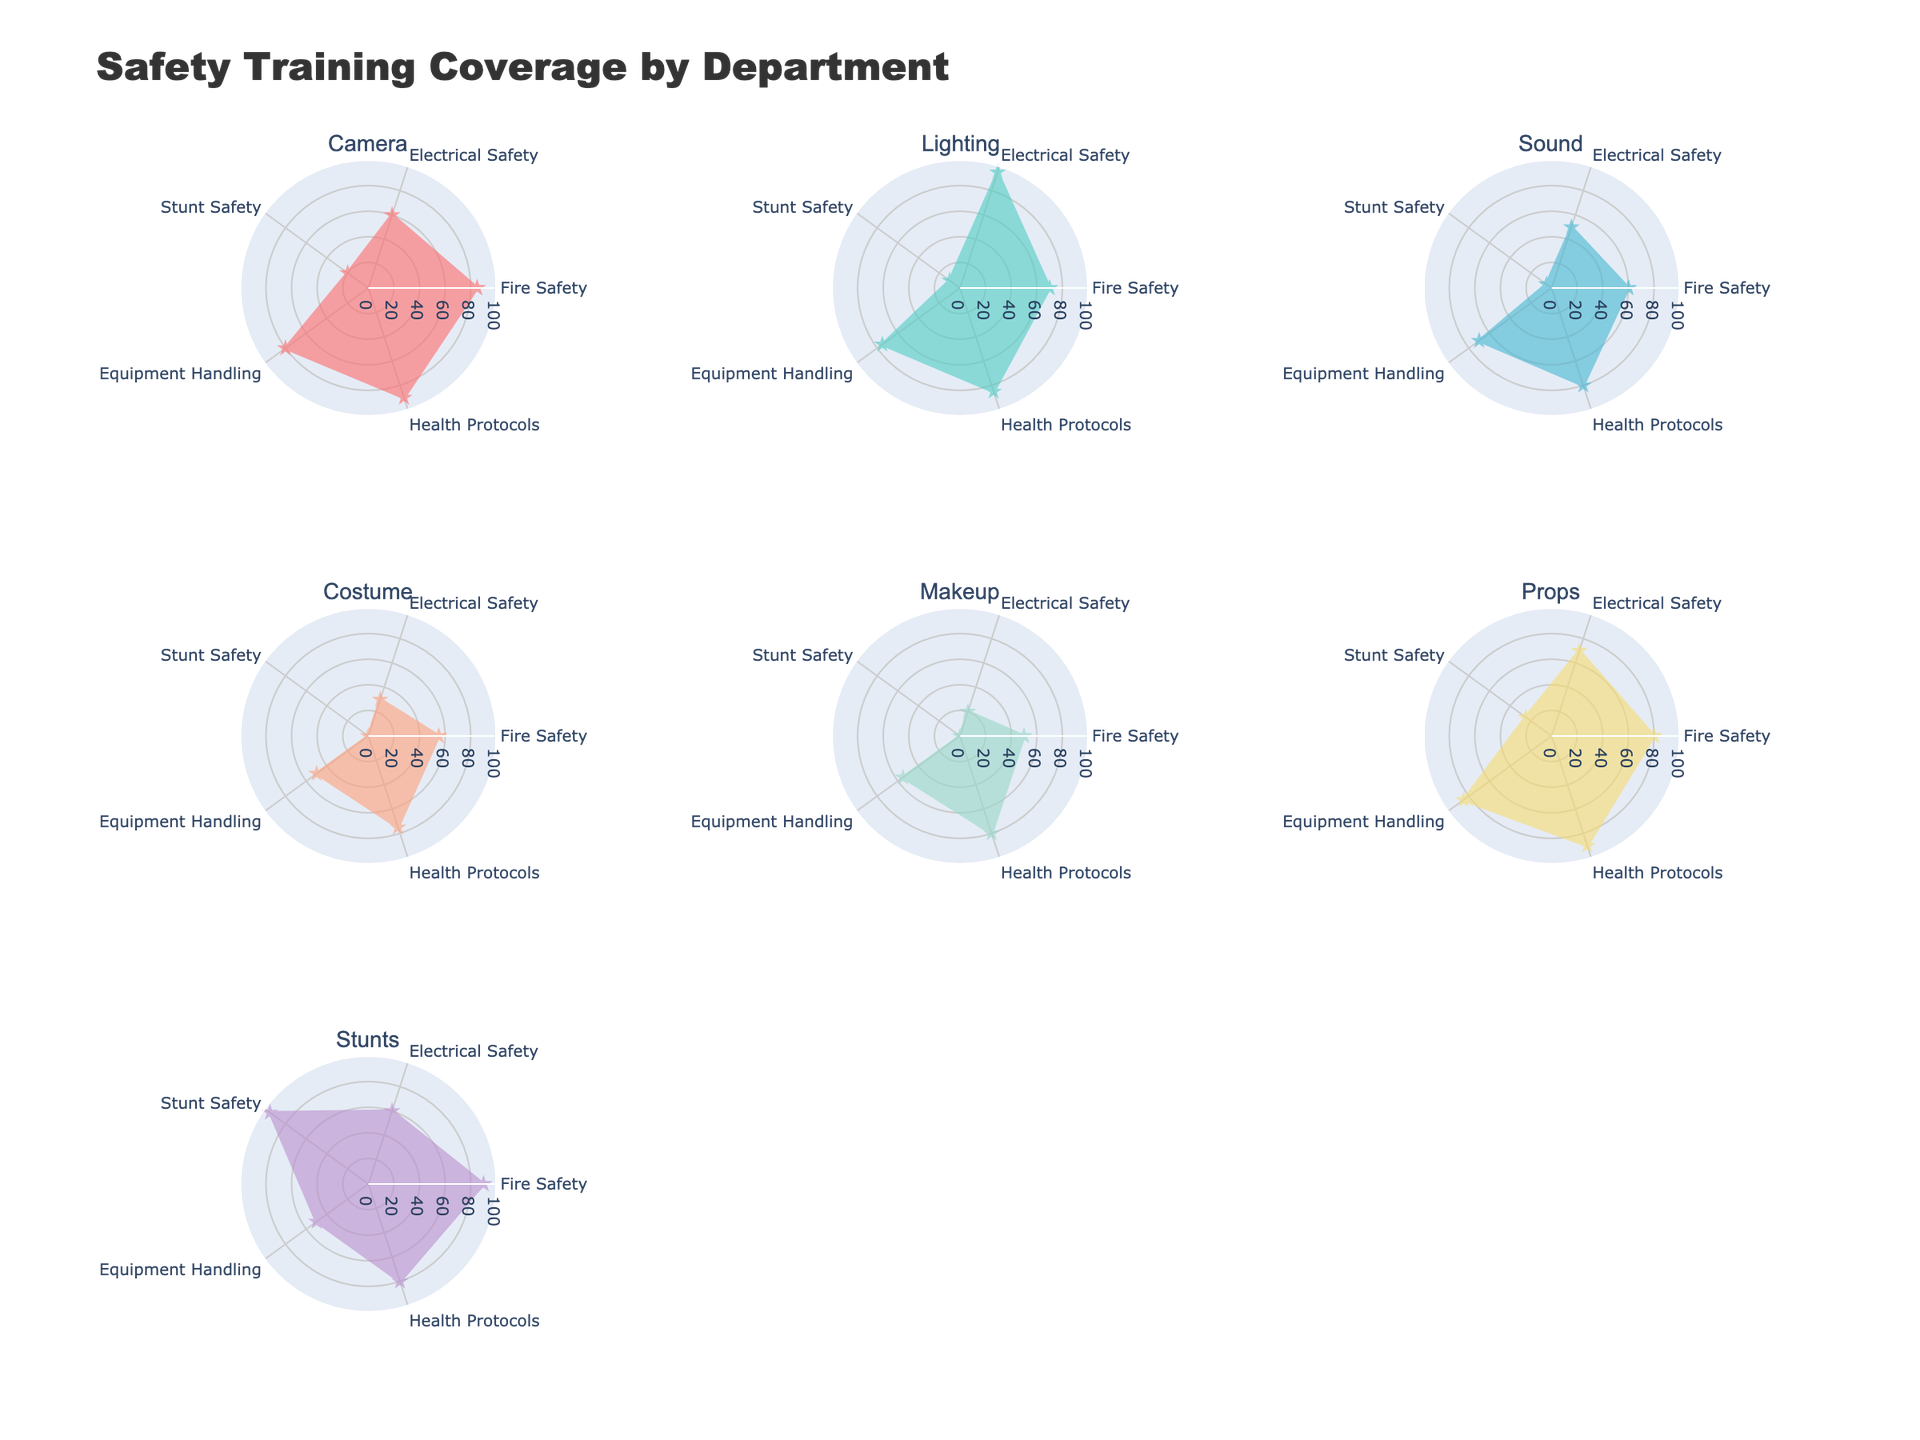What's the title of the figure? The title is displayed at the top center of the figure.
Answer: Safety Training Coverage by Department Which department has the highest coverage in Stunt Safety? Stunt Safety can be identified by locating the data point labeled 'Stunt Safety' on each department's radar plot. The Stunts department shows the highest coverage in this area.
Answer: Stunts What are the coverage values for Equipment Handling for the Camera and Props departments? Locate the Equipment Handling axis on the radar charts for both Camera and Props departments and read the corresponding values from the plots. Camera has 80 and Props have 85.
Answer: Camera: 80, Props: 85 How does the Fire Safety training of the Camera department compare to the Lighting department? Identify the Fire Safety data points for both the Camera and Lighting departments on their radar plots and compare them. Camera has 85, while Lighting has 70, so Camera's Fire Safety training is higher.
Answer: Camera: 85, Lighting: 70 Which department has the lowest combined coverage in Health Protocols and Stunt Safety? Sum the scores for Health Protocols and Stunt Safety for each department. The department with the lowest combined score is Sound (80 + 5 = 85).
Answer: Sound Rank the departments in descending order based on their Electrical Safety coverage. Locate the Electrical Safety data points on each radar plot, compare them, and rank: Lighting (95), Props (70), Camera & Stunts (60), Sound (50), Costume (30), Makeup (20).
Answer: Lighting, Props, Camera & Stunts, Sound, Costume, Makeup Is there a department where Stunt Safety training is completely lacking? Search for departments with a value of 0 in the Stunt Safety axis on their radar plots. Both Costume and Makeup departments have 0.
Answer: Yes, Costume and Makeup What's the average Fire Safety coverage across all departments? Find the Fire Safety coverage values for all departments (85, 70, 60, 55, 50, 80, 90), sum them (490), and divide by the number of departments (490/7).
Answer: 70 Which department shows the most balanced safety training across all categories? Check the radar plots for the department with the most uniform shape, which indicates balanced coverage across all categories. Props appear to be the most balanced.
Answer: Props How much greater is the Equipment Handling coverage for the Props department compared to the Costume department? Subtract the Equipment Handling value for Costume (50) from the value for Props (85). The result is 85 - 50 = 35.
Answer: 35 